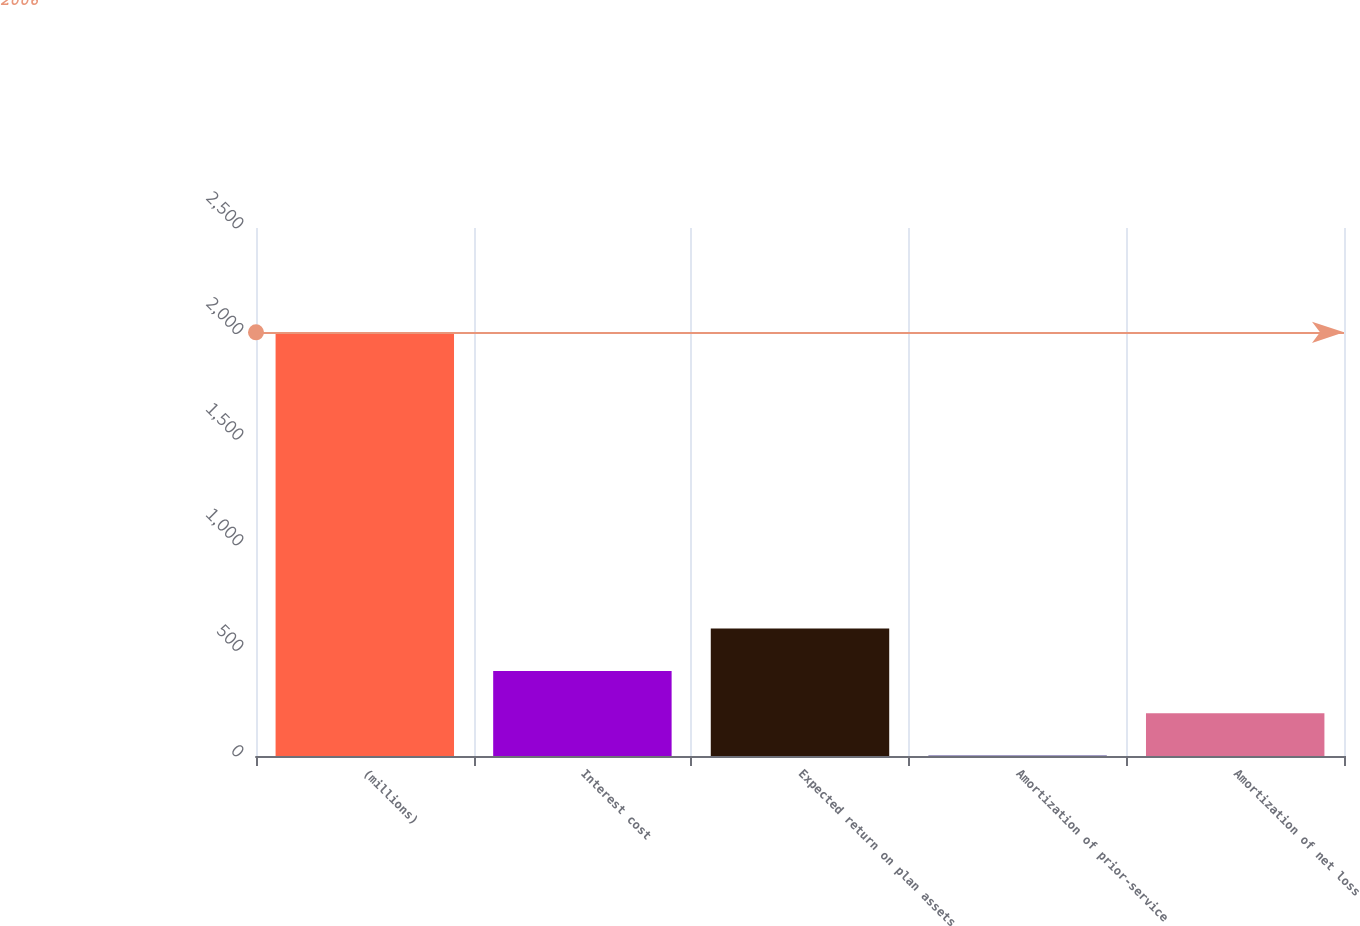<chart> <loc_0><loc_0><loc_500><loc_500><bar_chart><fcel>(millions)<fcel>Interest cost<fcel>Expected return on plan assets<fcel>Amortization of prior-service<fcel>Amortization of net loss<nl><fcel>2006<fcel>402.8<fcel>603.2<fcel>2<fcel>202.4<nl></chart> 